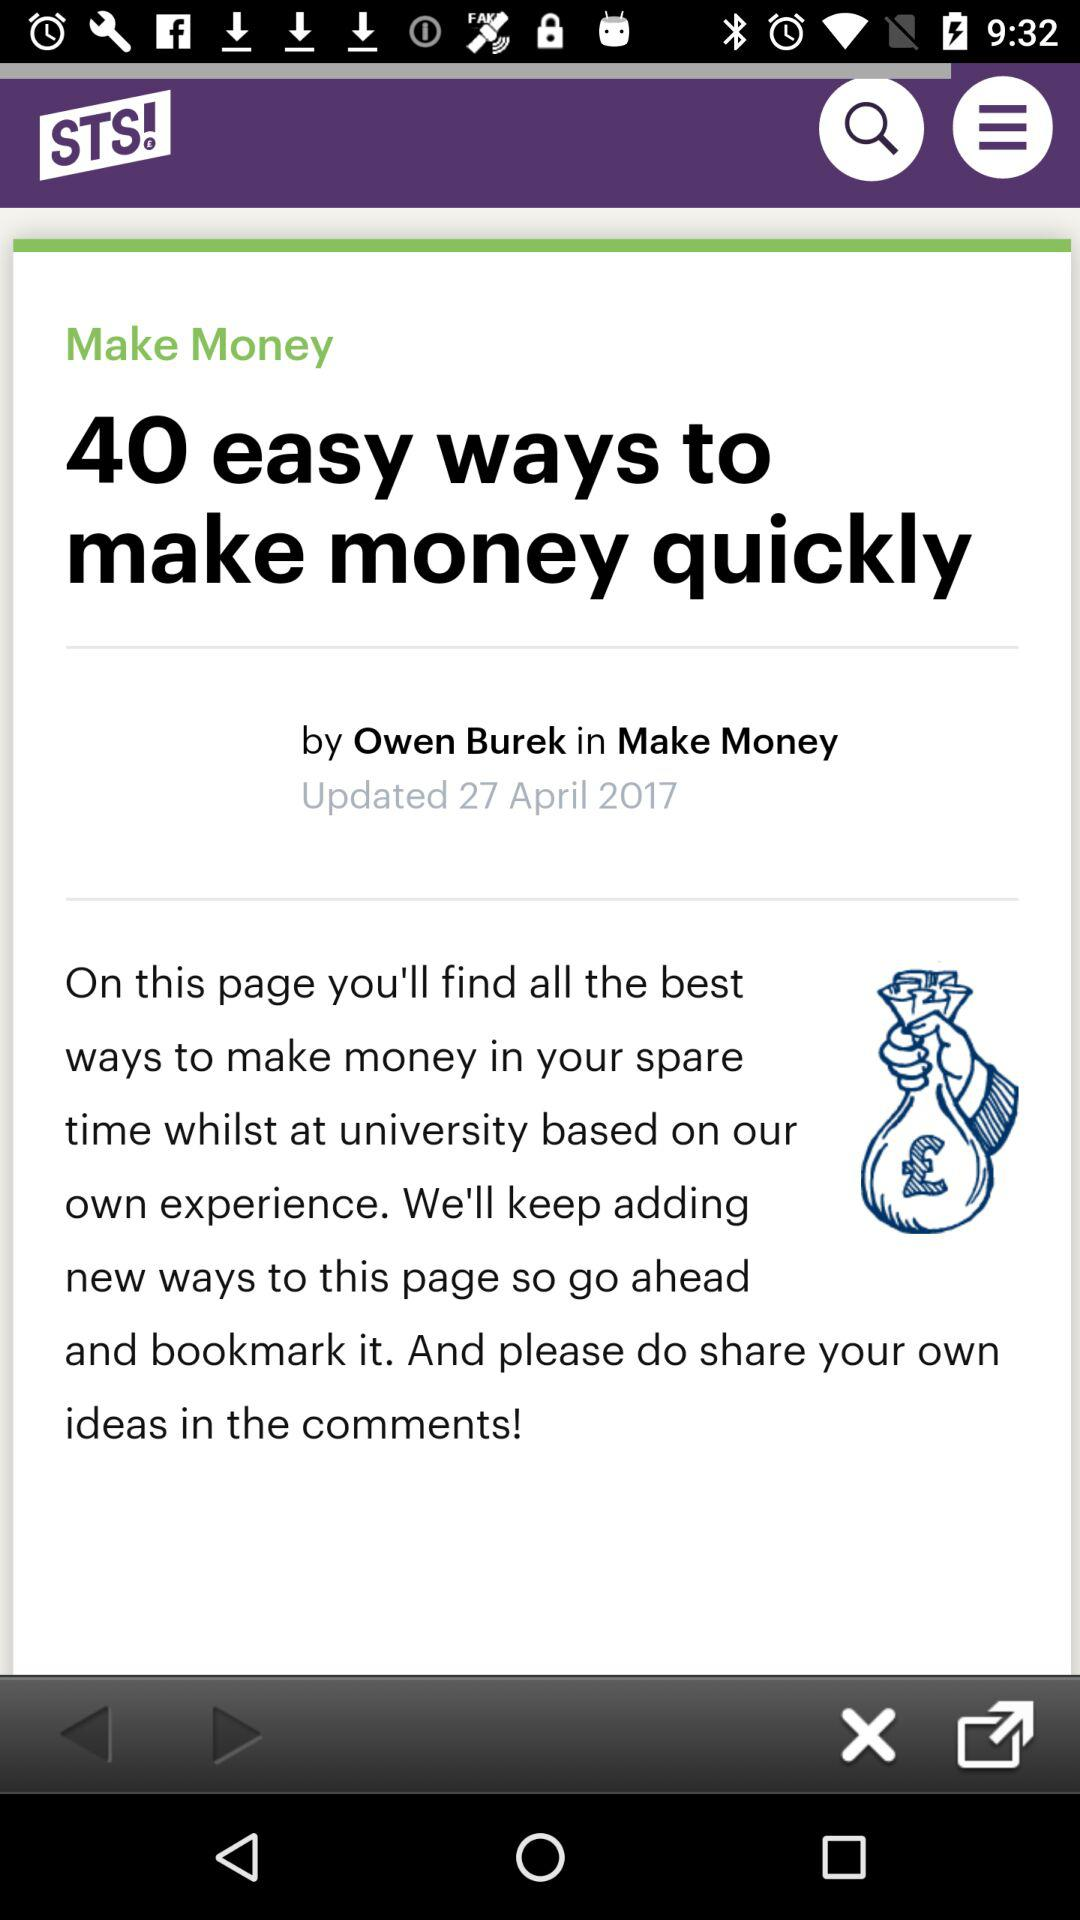When was the article updated? The article was updated on April 27, 2017. 